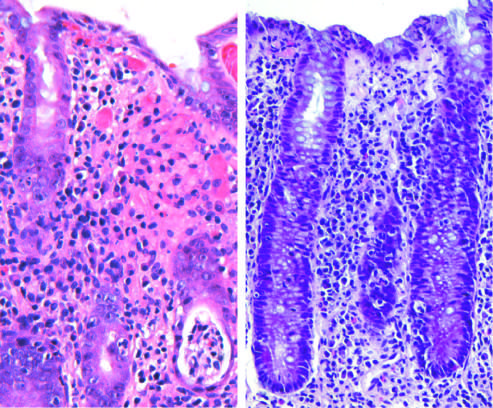what does campylobacter jejuni infection produce?
Answer the question using a single word or phrase. Acute 